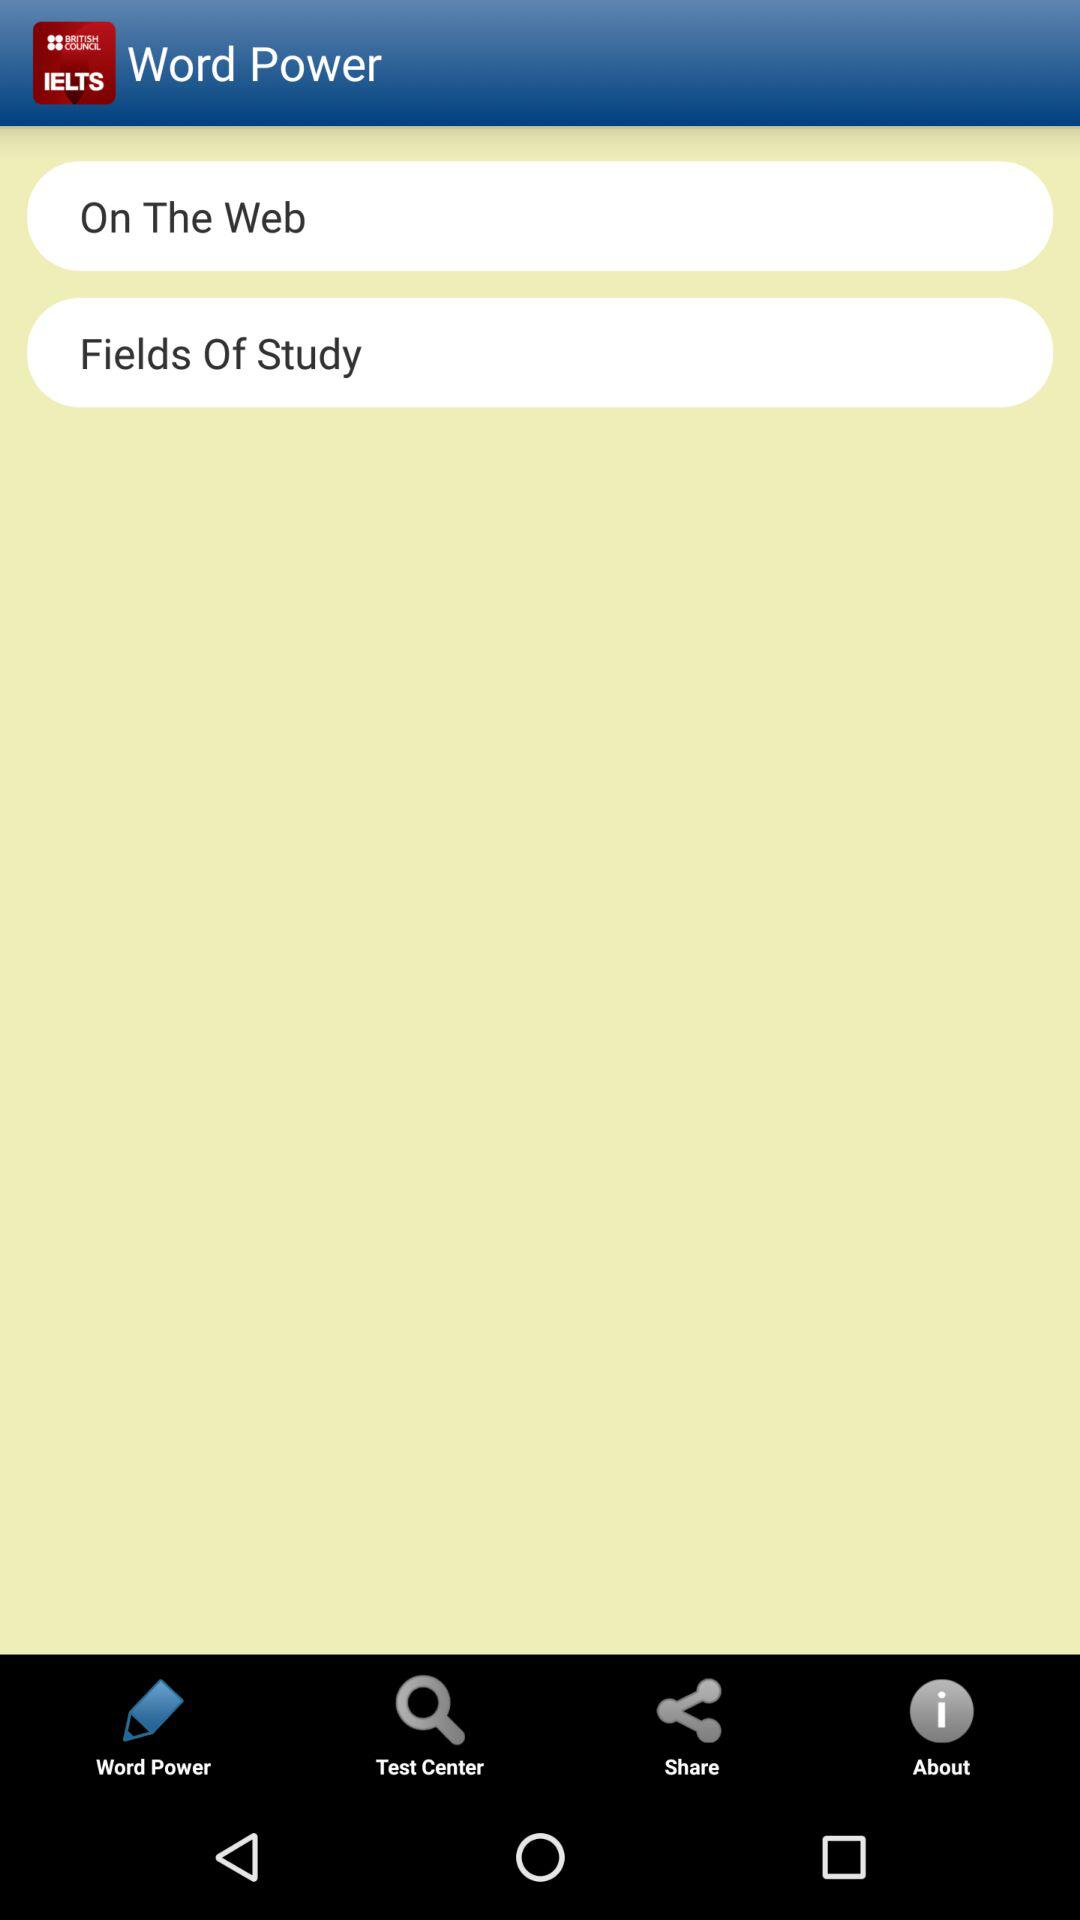Which options are available for sharing?
When the provided information is insufficient, respond with <no answer>. <no answer> 